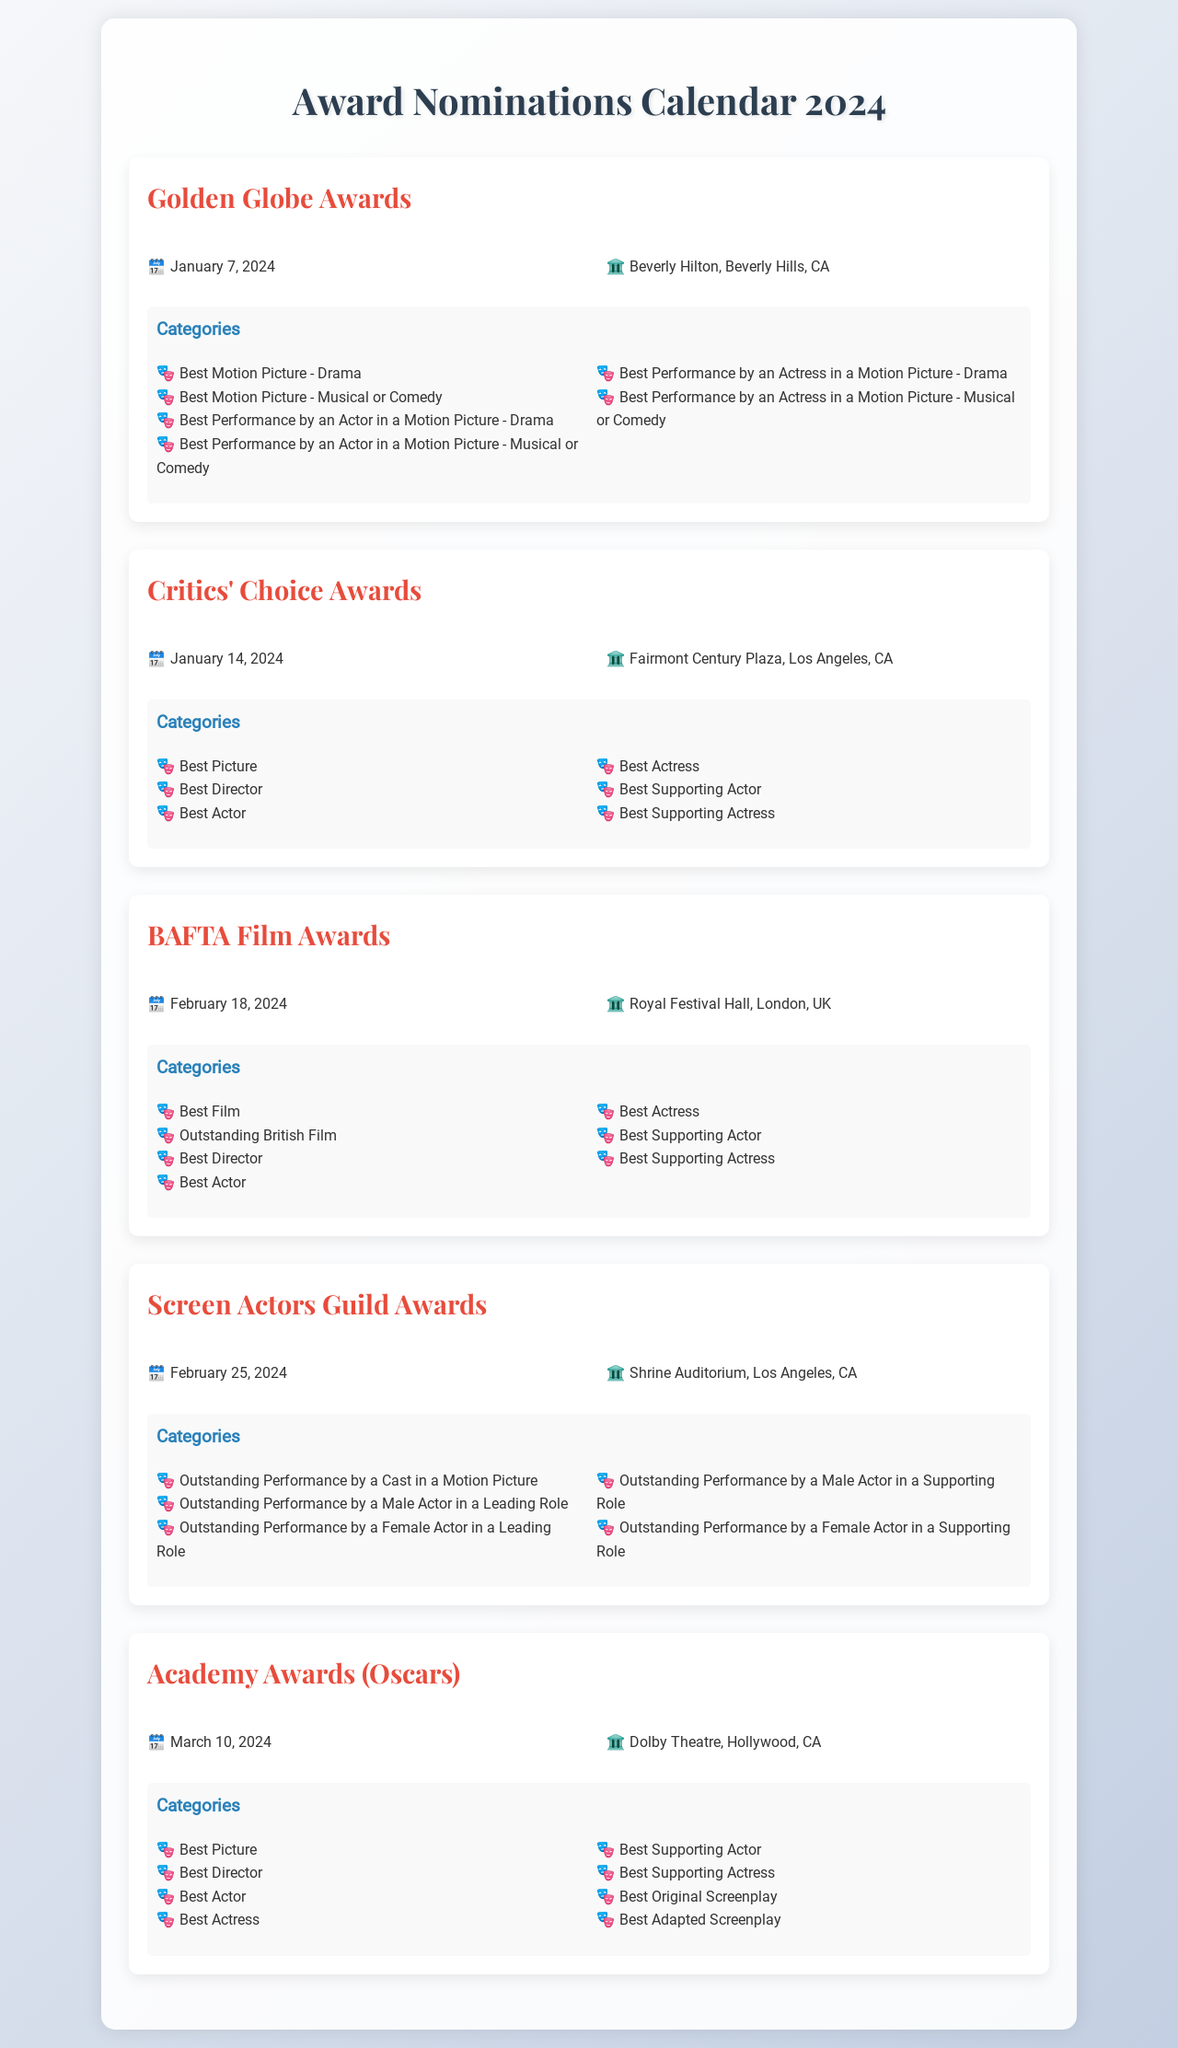What is the date of the Golden Globe Awards? The date of the Golden Globe Awards is specified in the document as January 7, 2024.
Answer: January 7, 2024 Where will the BAFTA Film Awards take place? The venue for the BAFTA Film Awards is detailed in the document as Royal Festival Hall, London, UK.
Answer: Royal Festival Hall, London, UK Which event occurs on February 25, 2024? The event occurring on February 25, 2024, as stated in the document, is the Screen Actors Guild Awards.
Answer: Screen Actors Guild Awards What category is awarded at the Academy Awards for screenplay? The document lists Best Original Screenplay and Best Adapted Screenplay as categories for the Academy Awards.
Answer: Best Original Screenplay How many categories are listed for the Critics' Choice Awards? By counting the categories in the document, there are six categories listed for the Critics' Choice Awards.
Answer: Six Which award recognizes performances by a cast in a motion picture? The award that recognizes performances by a cast in a motion picture is highlighted in the document as Outstanding Performance by a Cast in a Motion Picture.
Answer: Outstanding Performance by a Cast in a Motion Picture What is the first event listed in the calendar? The document indicates the first event listed in the calendar is the Golden Globe Awards.
Answer: Golden Globe Awards Which venue is associated with the Oscars? The venue associated with the Oscars, according to the document, is the Dolby Theatre, Hollywood, CA.
Answer: Dolby Theatre, Hollywood, CA 